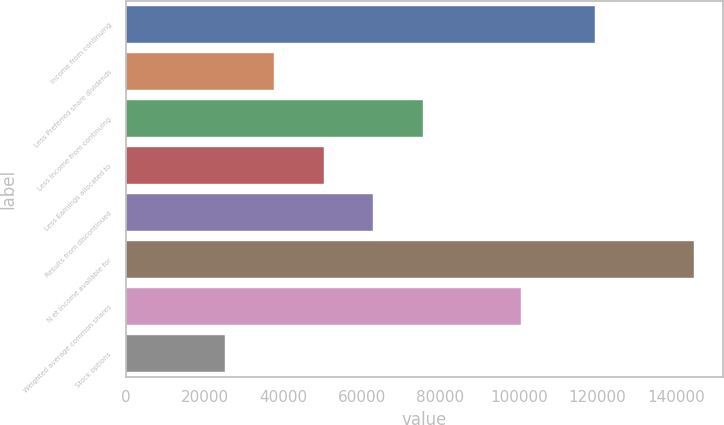Convert chart. <chart><loc_0><loc_0><loc_500><loc_500><bar_chart><fcel>Income from continuing<fcel>Less Preferred share dividends<fcel>Less Income from continuing<fcel>Less Earnings allocated to<fcel>Results from discontinued<fcel>N et income available for<fcel>Weighted average common shares<fcel>Stock options<nl><fcel>119491<fcel>37755.3<fcel>75510.6<fcel>50340.4<fcel>62925.5<fcel>144661<fcel>100681<fcel>25170.2<nl></chart> 